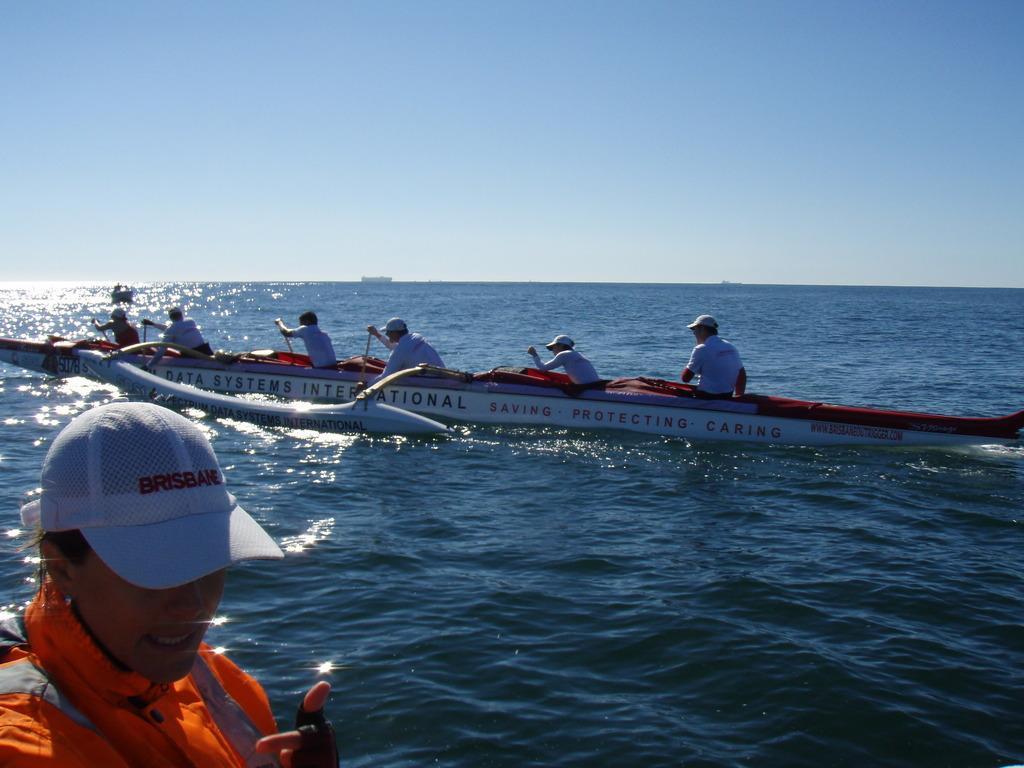Describe this image in one or two sentences. In this image there is the sky, there is a sea, there is a boat truncated, there are persons on the boat, there are persons rowing the boat, there is a person truncated towards the bottom of the image. 